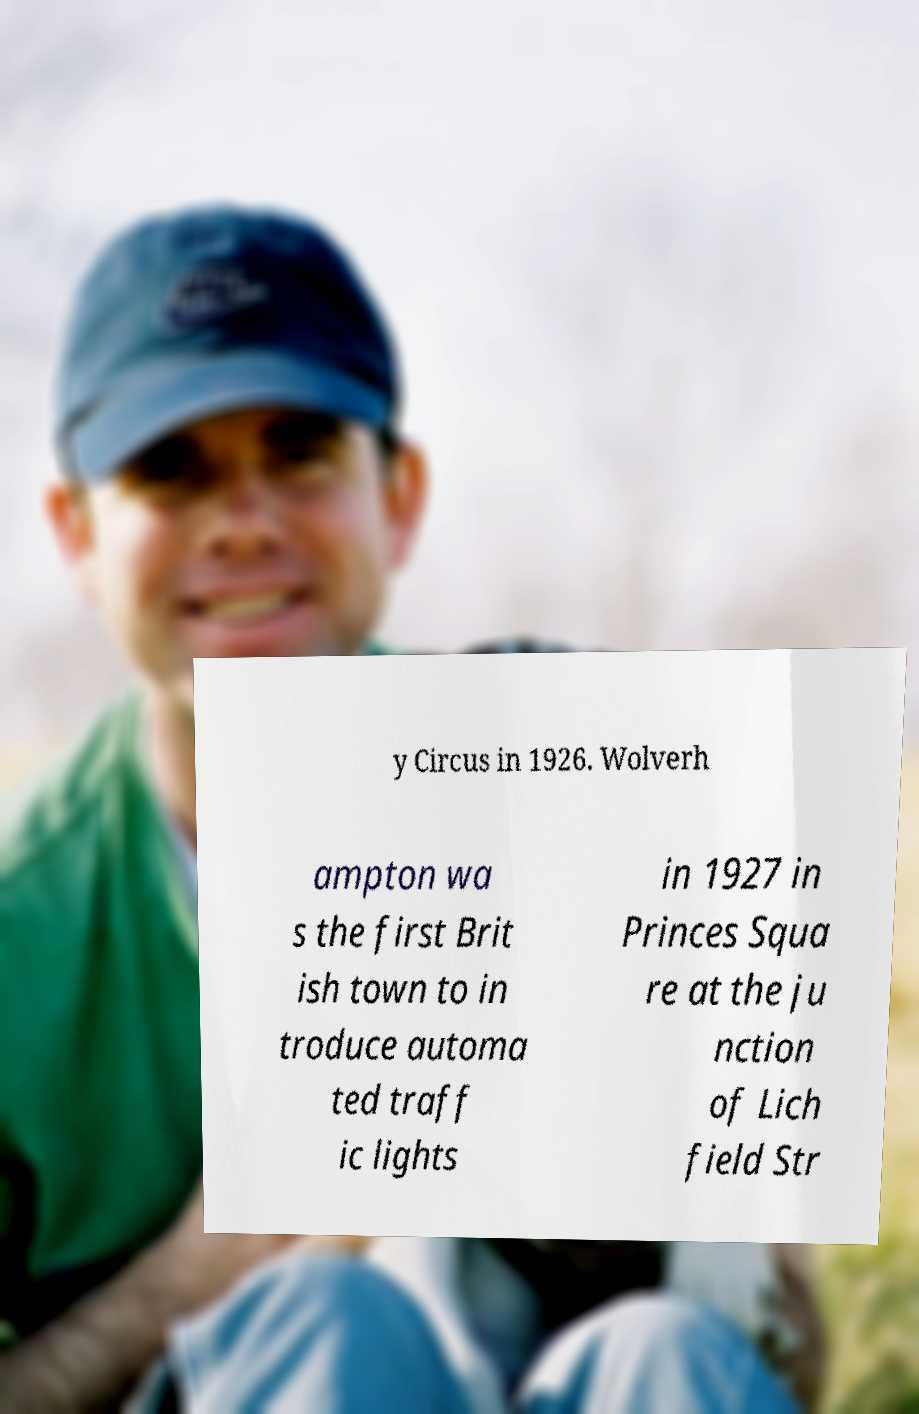I need the written content from this picture converted into text. Can you do that? y Circus in 1926. Wolverh ampton wa s the first Brit ish town to in troduce automa ted traff ic lights in 1927 in Princes Squa re at the ju nction of Lich field Str 